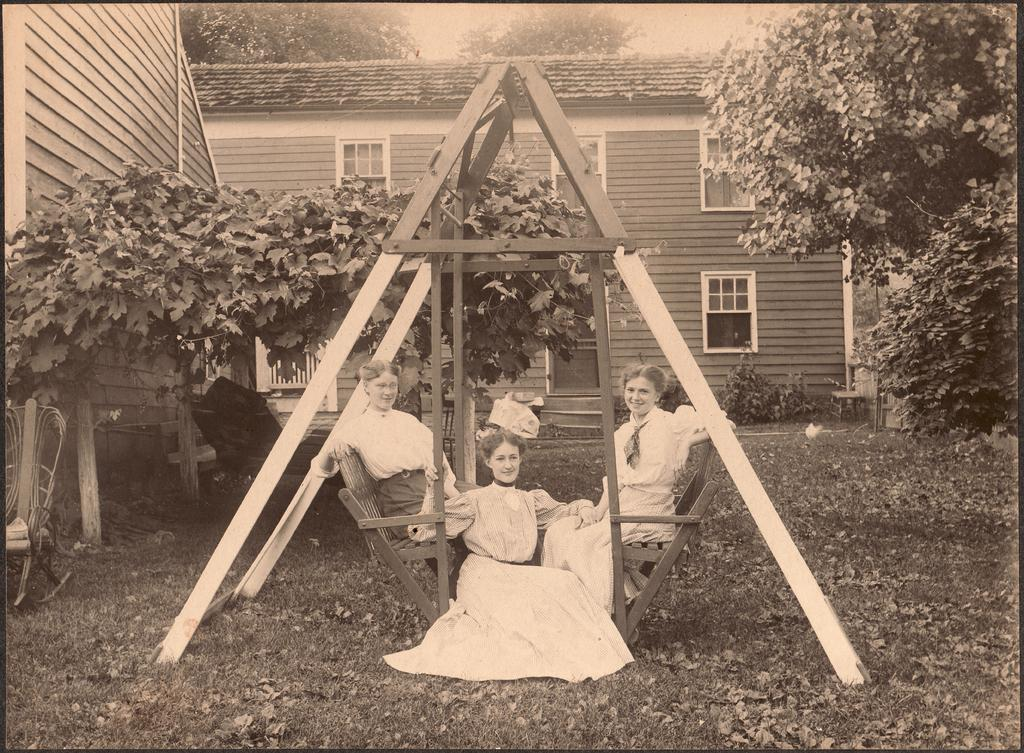What is located in the center of the image? There is a stand in the center of the image. What are people doing on the stand? People are sitting on the stand. What can be seen in the background of the image? There is a building and trees in the background of the image. Where is the chair located in the image? The chair is on the left side of the image. What type of root can be seen growing from the chair in the image? There is no root growing from the chair in the image; it is a standalone chair. 